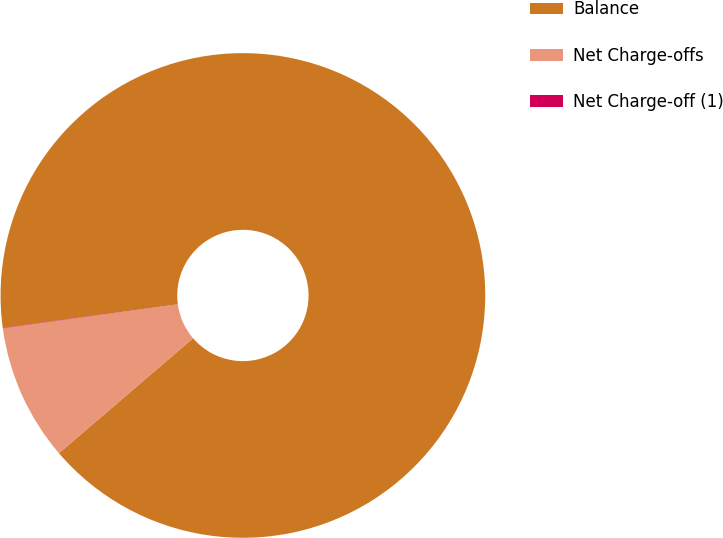<chart> <loc_0><loc_0><loc_500><loc_500><pie_chart><fcel>Balance<fcel>Net Charge-offs<fcel>Net Charge-off (1)<nl><fcel>90.85%<fcel>9.12%<fcel>0.03%<nl></chart> 